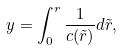<formula> <loc_0><loc_0><loc_500><loc_500>y = \int _ { 0 } ^ { r } { \frac { 1 } { c ( \tilde { r } ) } d \tilde { r } } ,</formula> 